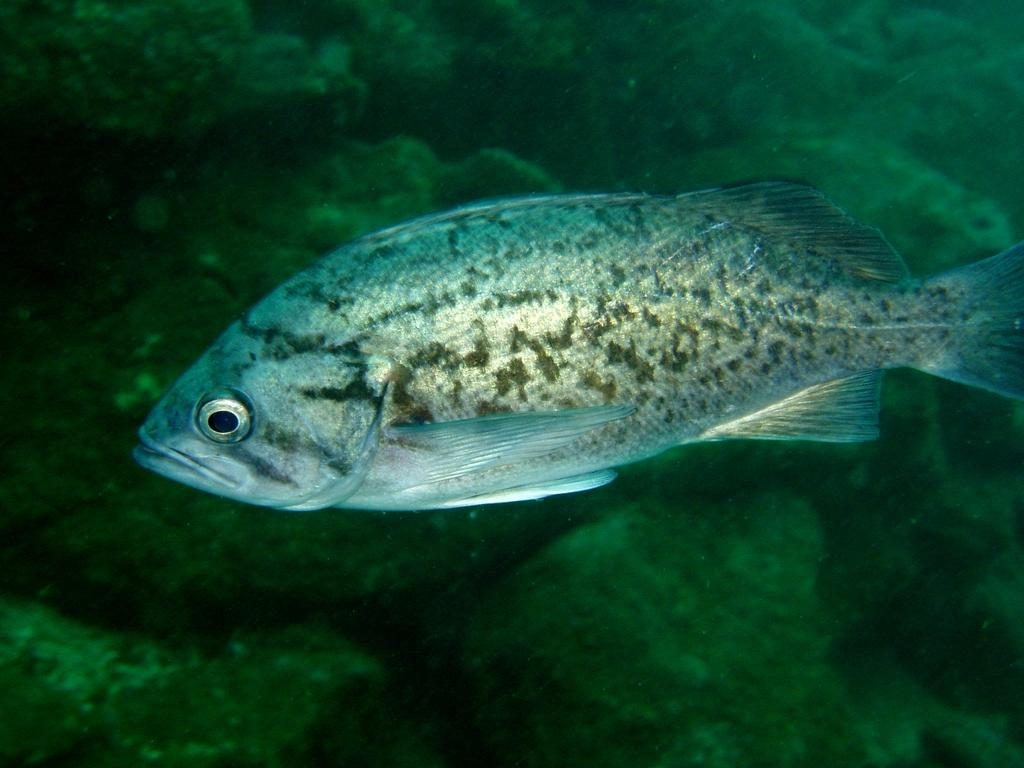What is in the water in the image? There is a fish in the water. What can be seen in the background of the image? There are rocks in the background of the image. What type of light is being used to create the sun in the image? There is no sun present in the image; it only features a fish in the water and rocks in the background. 